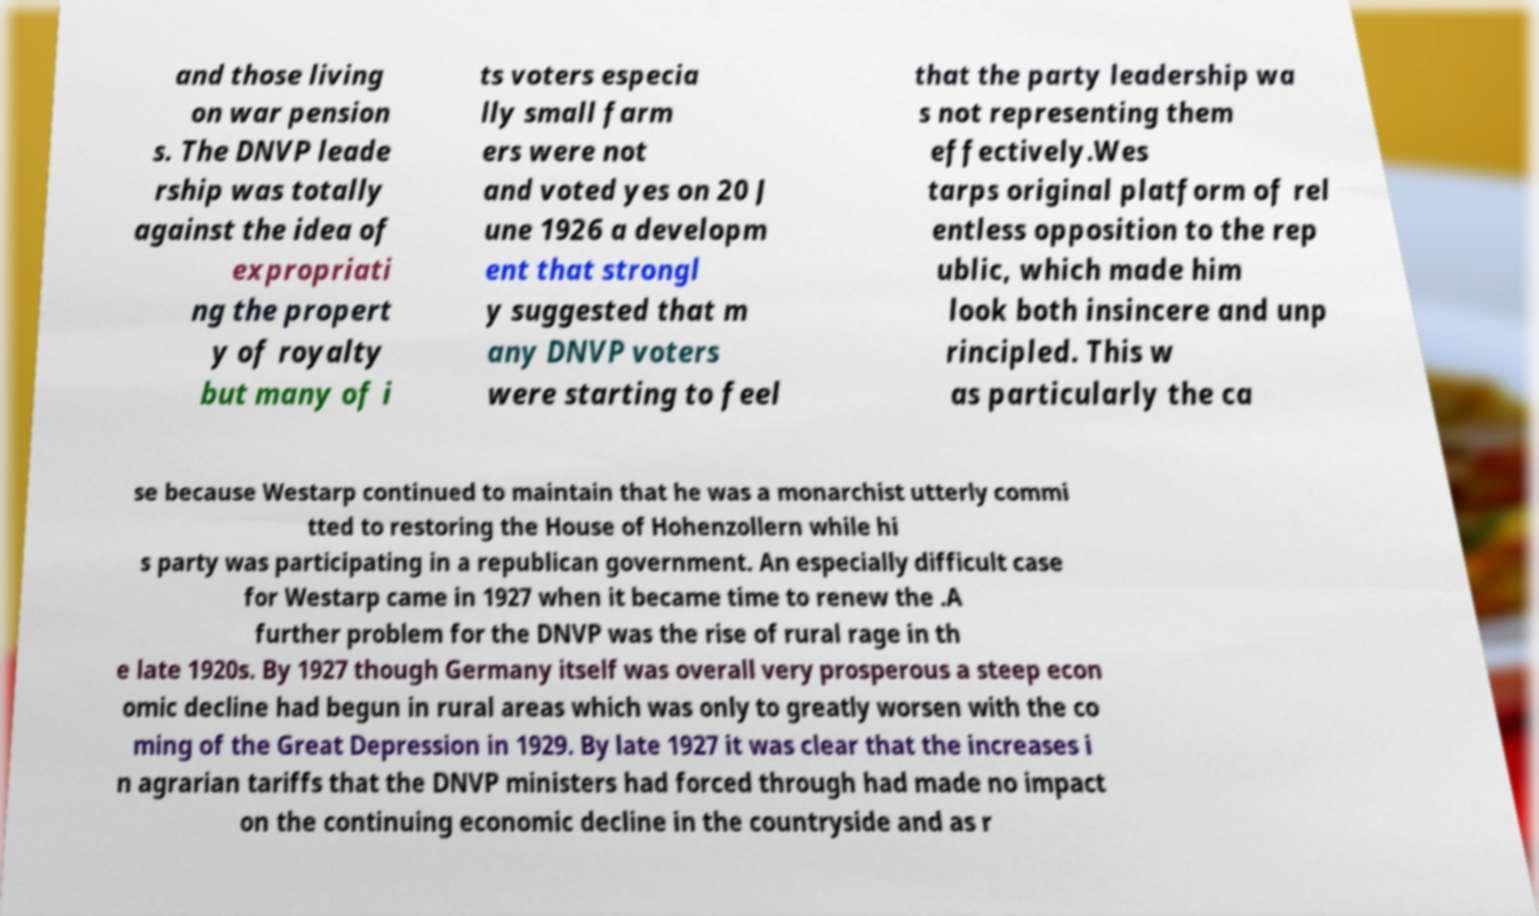What messages or text are displayed in this image? I need them in a readable, typed format. and those living on war pension s. The DNVP leade rship was totally against the idea of expropriati ng the propert y of royalty but many of i ts voters especia lly small farm ers were not and voted yes on 20 J une 1926 a developm ent that strongl y suggested that m any DNVP voters were starting to feel that the party leadership wa s not representing them effectively.Wes tarps original platform of rel entless opposition to the rep ublic, which made him look both insincere and unp rincipled. This w as particularly the ca se because Westarp continued to maintain that he was a monarchist utterly commi tted to restoring the House of Hohenzollern while hi s party was participating in a republican government. An especially difficult case for Westarp came in 1927 when it became time to renew the .A further problem for the DNVP was the rise of rural rage in th e late 1920s. By 1927 though Germany itself was overall very prosperous a steep econ omic decline had begun in rural areas which was only to greatly worsen with the co ming of the Great Depression in 1929. By late 1927 it was clear that the increases i n agrarian tariffs that the DNVP ministers had forced through had made no impact on the continuing economic decline in the countryside and as r 